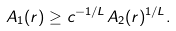Convert formula to latex. <formula><loc_0><loc_0><loc_500><loc_500>A _ { 1 } ( r ) \geq c ^ { - 1 / L } A _ { 2 } ( r ) ^ { 1 / L } .</formula> 